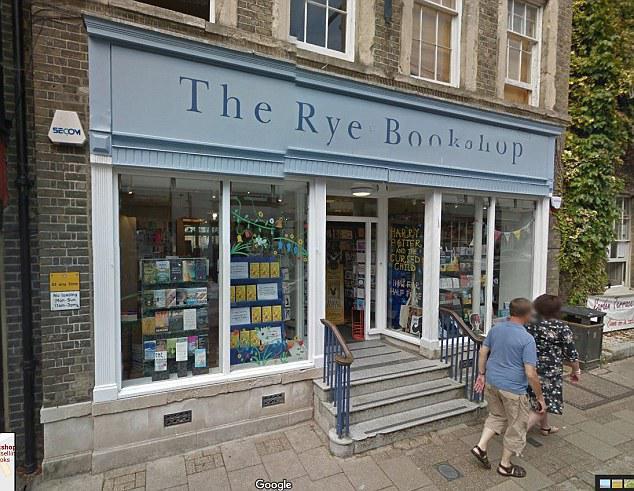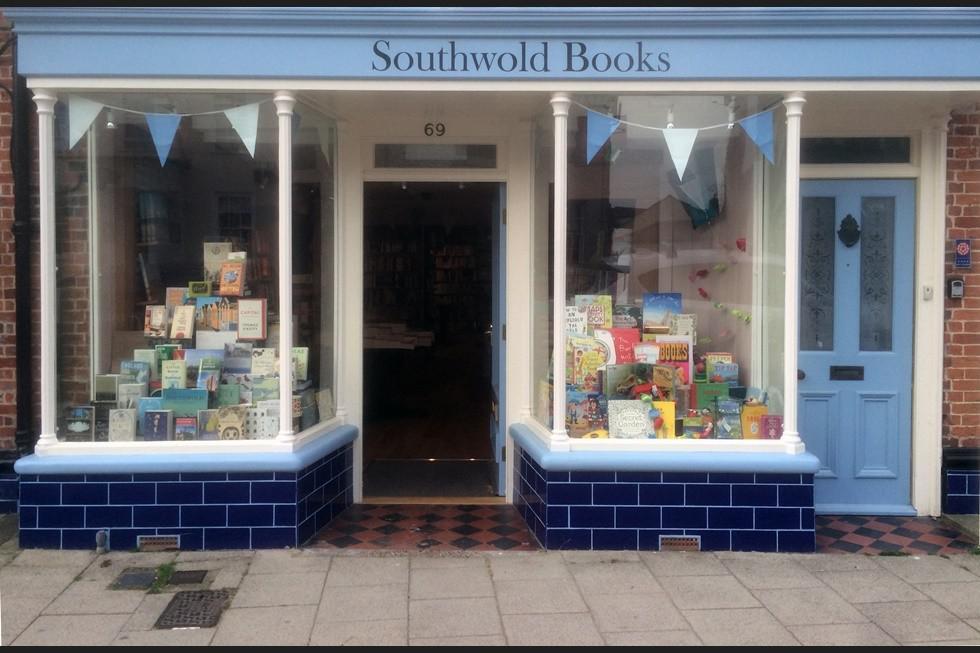The first image is the image on the left, the second image is the image on the right. Examine the images to the left and right. Is the description "There is an open door between two display windows of a shelf of books and at the bottom there a blue bricks." accurate? Answer yes or no. Yes. The first image is the image on the left, the second image is the image on the right. Considering the images on both sides, is "The bookstore on the right has a banner of pennants in different shades of blue." valid? Answer yes or no. Yes. 